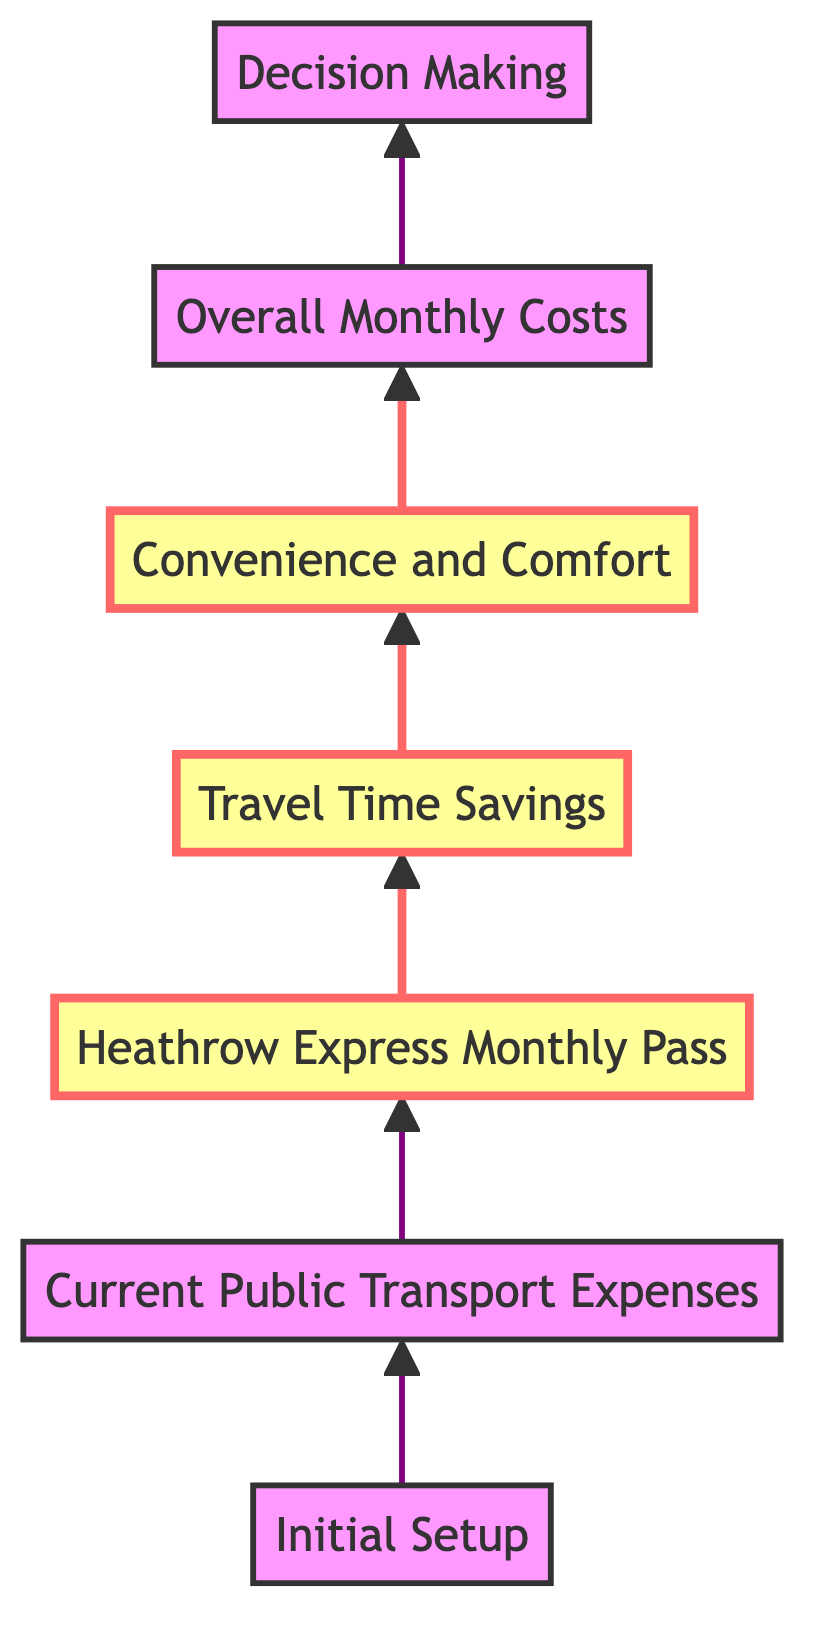What is the title of the first node? The first node is labeled "Initial Setup," which is the starting point of the flowchart.
Answer: Initial Setup How many nodes are present in the diagram? There are a total of seven nodes in the diagram, each representing a different stage in the expense transition process.
Answer: Seven What is the last node titled? The last node in the diagram is titled "Decision Making," which concludes the flow of the chart.
Answer: Decision Making Which node highlights the preparation of travel pass expenses? The node labeled "Heathrow Express Monthly Pass" is highlighted and focuses on calculating the costs associated with purchasing the pass.
Answer: Heathrow Express Monthly Pass What two factors are compared in the node before the last one? The node "Overall Monthly Costs" summarizes the total expenses that account for the transition, which involves both public transport and Heathrow Express.
Answer: Overall Monthly Costs Which node indicates the evaluation of current transport costs? The node "Current Public Transport Expenses" assesses existing monthly costs related to public transportation methods.
Answer: Current Public Transport Expenses What is the purpose of the "Travel Time Savings" node? The purpose of the "Travel Time Savings" node is to estimate the amount of time saved by using Heathrow Express instead of public transport for each journey.
Answer: Travel Time Savings How does one transition from public transport costs to Heathrow Express expenses according to the diagram? The flowchart indicates that after evaluating public transport expenses, the next step is to compute the costs linked to the Heathrow Express pass, following a logical sequence.
Answer: Heathrow Express Monthly Pass What key aspects are assessed in the node titled "Convenience and Comfort"? This node considers the perceived added value when commuting via Heathrow Express, such as comfort and fewer transfers compared to public transport options.
Answer: Convenience and Comfort 